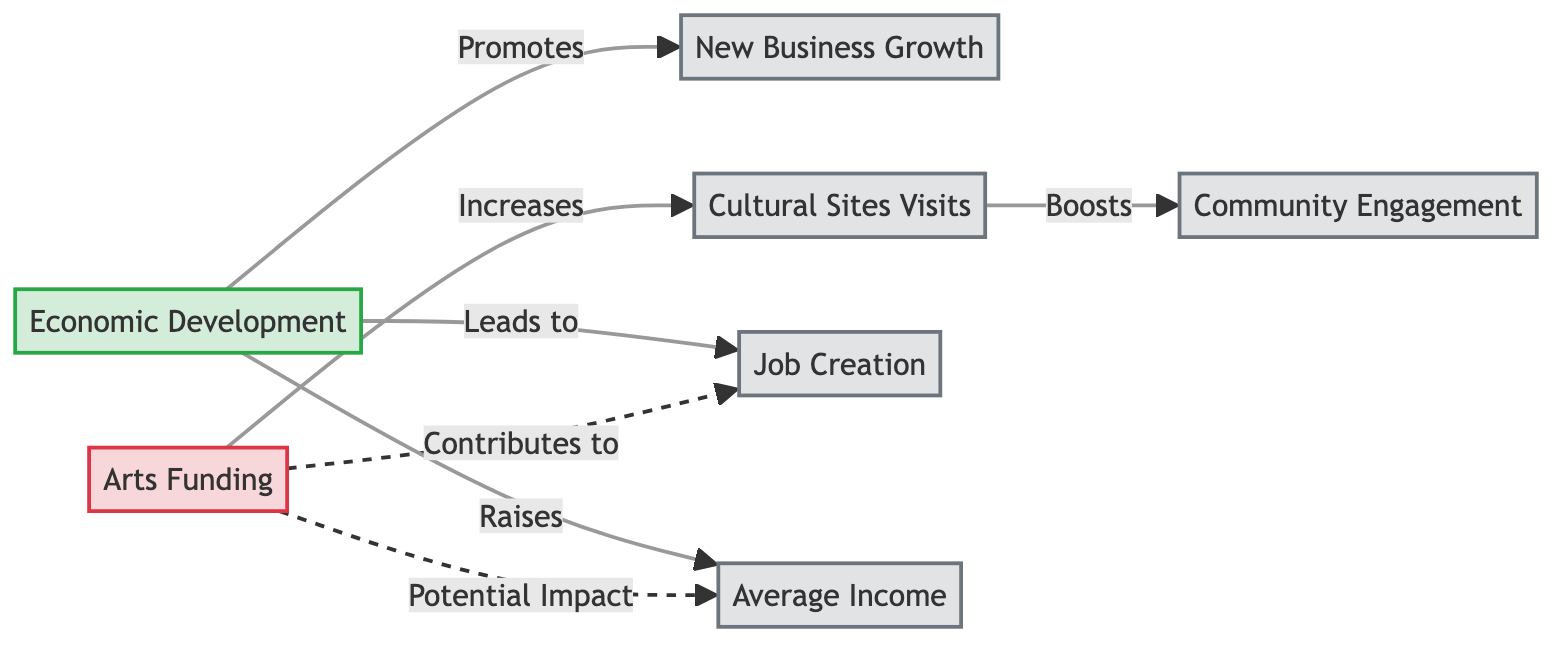What is connected to Economic Development? Economic Development has direct connections to New Business Growth, Job Creation, and Average Income in the diagram.
Answer: New Business Growth, Job Creation, Average Income What is the relationship between Arts Funding and Cultural Sites Visits? Arts Funding directly increases Cultural Sites Visits in the diagram, highlighted by a solid arrow indicating a positive effect.
Answer: Increases How many nodes are there in the diagram? By counting all individual nodes represented in the diagram, there are a total of six nodes: Economic Development, Arts Funding, New Business Growth, Cultural Sites Visits, Job Creation, and Average Income.
Answer: Six What does Cultural Sites Visits contribute to? Cultural Sites Visits boosts Community Engagement, as shown by the directional arrow leading from it to Community Engagement in the diagram.
Answer: Community Engagement How does Economic Development affect Average Income? Economic Development raises Average Income, indicated by a solid arrow in the diagram that illustrates a direct positive effect.
Answer: Raises What type of relationship exists between Arts Funding and Job Creation? The diagram shows a dashed line connecting Arts Funding to Job Creation, indicating that Arts Funding contributes to Job Creation, although this may not be a direct effect.
Answer: Contributes to What potential impact does Arts Funding have on Average Income? The relationship between Arts Funding and Average Income is shown as a dashed line, representing a potential impact rather than a direct effect in the diagram, suggesting a weaker connection.
Answer: Potential Impact Which node has an indirect effect of impact on Community Engagement? The indirect effect on Community Engagement comes through Cultural Sites Visits, which is connected to Arts Funding. This means Community Engagement is impacted through another node.
Answer: Cultural Sites Visits What is the overall theme represented in the diagram? The overall theme of the diagram compares Economic Development and Arts Funding over a decade, illustrating their effects on various socio-economic outcomes.
Answer: Comparative Analysis 